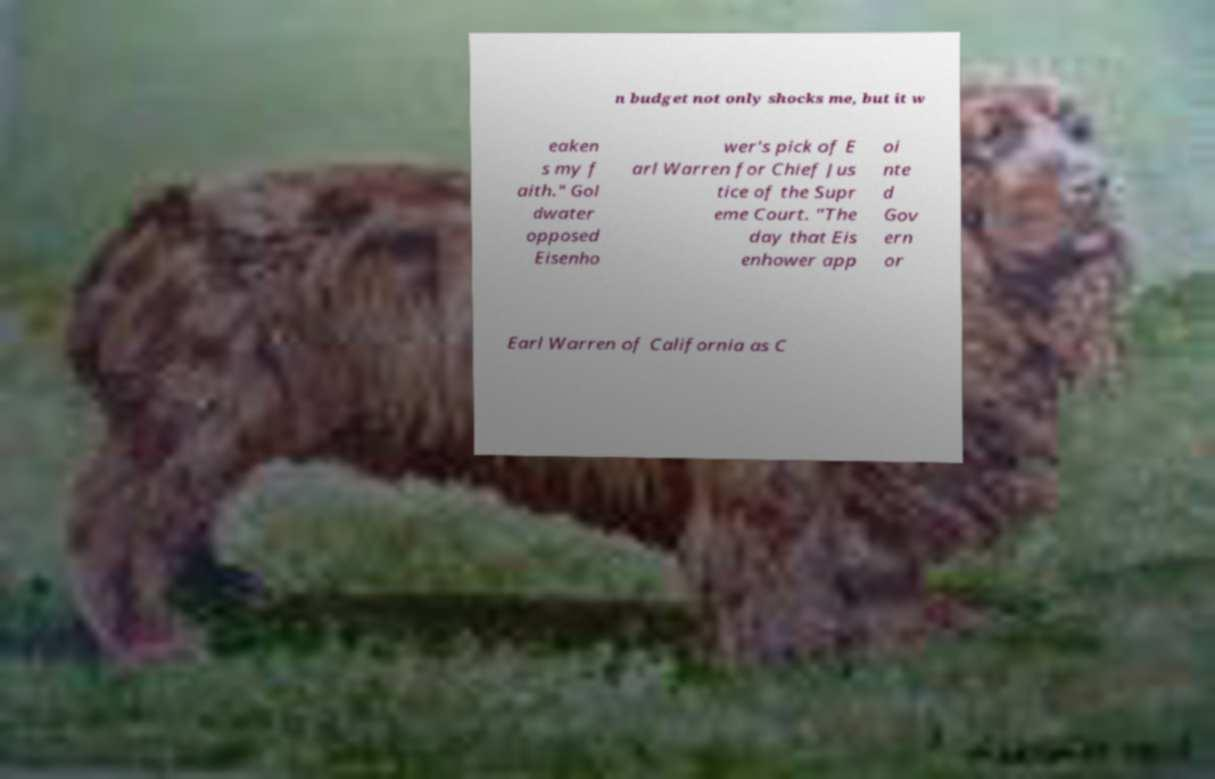Can you read and provide the text displayed in the image?This photo seems to have some interesting text. Can you extract and type it out for me? n budget not only shocks me, but it w eaken s my f aith." Gol dwater opposed Eisenho wer's pick of E arl Warren for Chief Jus tice of the Supr eme Court. "The day that Eis enhower app oi nte d Gov ern or Earl Warren of California as C 